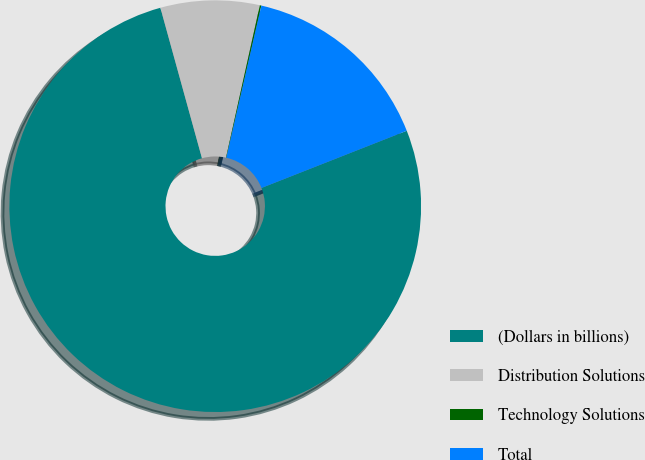<chart> <loc_0><loc_0><loc_500><loc_500><pie_chart><fcel>(Dollars in billions)<fcel>Distribution Solutions<fcel>Technology Solutions<fcel>Total<nl><fcel>76.68%<fcel>7.77%<fcel>0.12%<fcel>15.43%<nl></chart> 